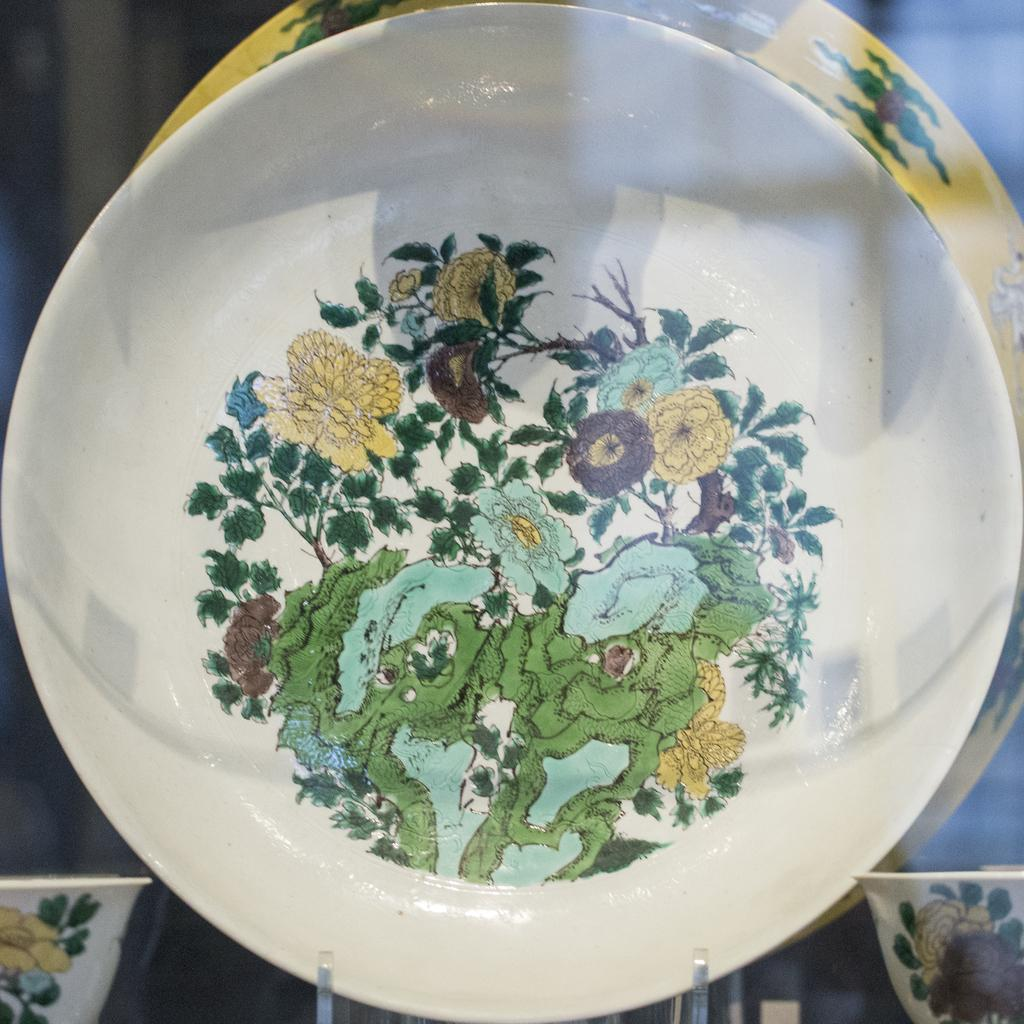What object is present in the image that typically holds food? There is a plate in the image. What is depicted on the plate? The plate contains paintings of plants. How many balls are visible on the plate in the image? There are no balls visible on the plate in the image; it contains paintings of plants. Is there a bear interacting with the plants on the plate in the image? There is no bear present in the image, and the plants are depicted as paintings on the plate. 